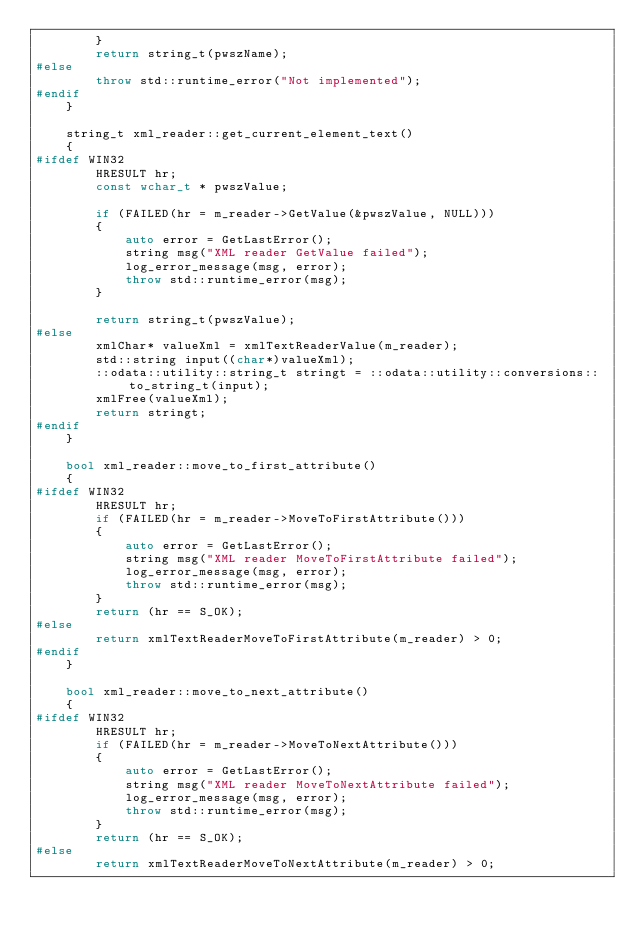<code> <loc_0><loc_0><loc_500><loc_500><_C++_>        }
        return string_t(pwszName);
#else
        throw std::runtime_error("Not implemented");
#endif
    }

    string_t xml_reader::get_current_element_text()
    {
#ifdef WIN32
        HRESULT hr;
        const wchar_t * pwszValue;

        if (FAILED(hr = m_reader->GetValue(&pwszValue, NULL)))
        {
            auto error = GetLastError();
            string msg("XML reader GetValue failed");
            log_error_message(msg, error);
            throw std::runtime_error(msg);
        }

        return string_t(pwszValue);
#else
        xmlChar* valueXml = xmlTextReaderValue(m_reader);
        std::string input((char*)valueXml);
        ::odata::utility::string_t stringt = ::odata::utility::conversions::to_string_t(input);
        xmlFree(valueXml);
        return stringt;
#endif
    }

    bool xml_reader::move_to_first_attribute()
    {
#ifdef WIN32
        HRESULT hr;
        if (FAILED(hr = m_reader->MoveToFirstAttribute()))
        {
            auto error = GetLastError();
            string msg("XML reader MoveToFirstAttribute failed");
            log_error_message(msg, error);
            throw std::runtime_error(msg);
        }
        return (hr == S_OK);
#else
        return xmlTextReaderMoveToFirstAttribute(m_reader) > 0;
#endif
    }

    bool xml_reader::move_to_next_attribute()
    {
#ifdef WIN32
        HRESULT hr;
        if (FAILED(hr = m_reader->MoveToNextAttribute()))
        {
            auto error = GetLastError();
            string msg("XML reader MoveToNextAttribute failed");
            log_error_message(msg, error);
            throw std::runtime_error(msg);
        }
        return (hr == S_OK);
#else
        return xmlTextReaderMoveToNextAttribute(m_reader) > 0;</code> 